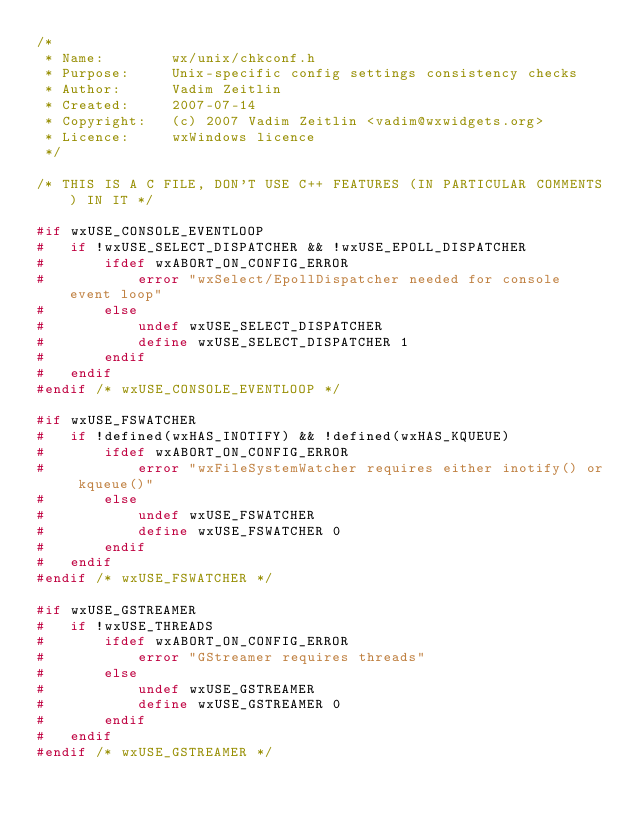<code> <loc_0><loc_0><loc_500><loc_500><_C_>/*
 * Name:        wx/unix/chkconf.h
 * Purpose:     Unix-specific config settings consistency checks
 * Author:      Vadim Zeitlin
 * Created:     2007-07-14
 * Copyright:   (c) 2007 Vadim Zeitlin <vadim@wxwidgets.org>
 * Licence:     wxWindows licence
 */

/* THIS IS A C FILE, DON'T USE C++ FEATURES (IN PARTICULAR COMMENTS) IN IT */

#if wxUSE_CONSOLE_EVENTLOOP
#   if !wxUSE_SELECT_DISPATCHER && !wxUSE_EPOLL_DISPATCHER
#       ifdef wxABORT_ON_CONFIG_ERROR
#           error "wxSelect/EpollDispatcher needed for console event loop"
#       else
#           undef wxUSE_SELECT_DISPATCHER
#           define wxUSE_SELECT_DISPATCHER 1
#       endif
#   endif
#endif /* wxUSE_CONSOLE_EVENTLOOP */

#if wxUSE_FSWATCHER
#   if !defined(wxHAS_INOTIFY) && !defined(wxHAS_KQUEUE)
#       ifdef wxABORT_ON_CONFIG_ERROR
#           error "wxFileSystemWatcher requires either inotify() or kqueue()"
#       else
#           undef wxUSE_FSWATCHER
#           define wxUSE_FSWATCHER 0
#       endif
#   endif
#endif /* wxUSE_FSWATCHER */

#if wxUSE_GSTREAMER
#   if !wxUSE_THREADS
#       ifdef wxABORT_ON_CONFIG_ERROR
#           error "GStreamer requires threads"
#       else
#           undef wxUSE_GSTREAMER
#           define wxUSE_GSTREAMER 0
#       endif
#   endif
#endif /* wxUSE_GSTREAMER */
</code> 